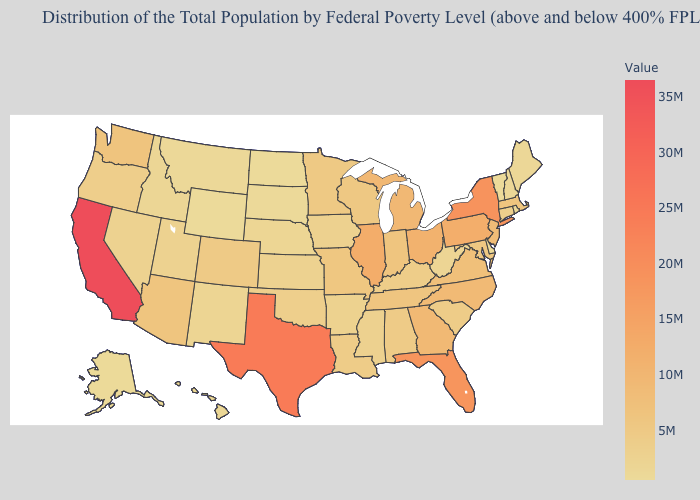Among the states that border Arkansas , which have the highest value?
Short answer required. Texas. Does New Hampshire have the lowest value in the Northeast?
Write a very short answer. No. Does Vermont have the lowest value in the USA?
Give a very brief answer. No. Which states have the lowest value in the USA?
Quick response, please. Wyoming. 